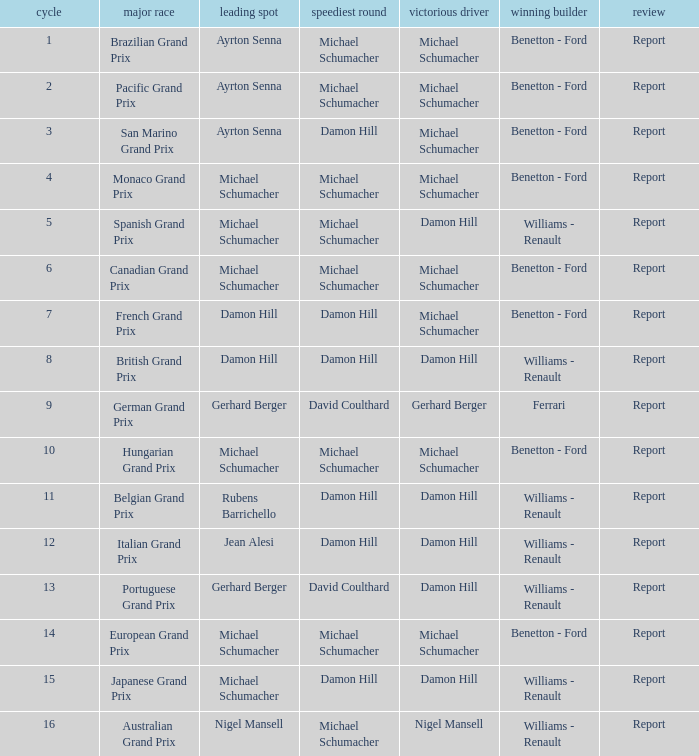Name the fastest lap for the brazilian grand prix Michael Schumacher. 